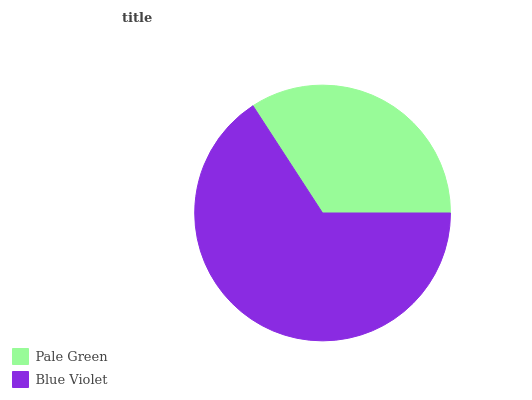Is Pale Green the minimum?
Answer yes or no. Yes. Is Blue Violet the maximum?
Answer yes or no. Yes. Is Blue Violet the minimum?
Answer yes or no. No. Is Blue Violet greater than Pale Green?
Answer yes or no. Yes. Is Pale Green less than Blue Violet?
Answer yes or no. Yes. Is Pale Green greater than Blue Violet?
Answer yes or no. No. Is Blue Violet less than Pale Green?
Answer yes or no. No. Is Blue Violet the high median?
Answer yes or no. Yes. Is Pale Green the low median?
Answer yes or no. Yes. Is Pale Green the high median?
Answer yes or no. No. Is Blue Violet the low median?
Answer yes or no. No. 